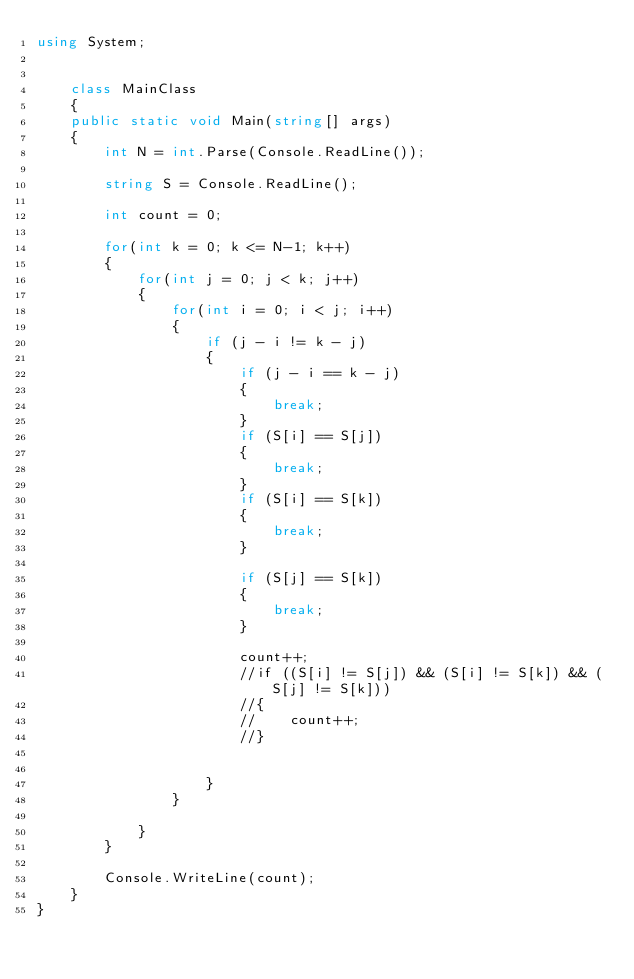Convert code to text. <code><loc_0><loc_0><loc_500><loc_500><_C#_>using System;


    class MainClass
    {
    public static void Main(string[] args)
    {
        int N = int.Parse(Console.ReadLine());

        string S = Console.ReadLine();

        int count = 0;

        for(int k = 0; k <= N-1; k++)
        {
            for(int j = 0; j < k; j++)
            {
                for(int i = 0; i < j; i++)
                {
                    if (j - i != k - j)
                    {
                        if (j - i == k - j)
                        {
                            break;
                        }
                        if (S[i] == S[j])
                        {
                            break;
                        }
                        if (S[i] == S[k])
                        {
                            break;
                        }

                        if (S[j] == S[k])
                        {
                            break;
                        }

                        count++;
                        //if ((S[i] != S[j]) && (S[i] != S[k]) && (S[j] != S[k]))
                        //{
                        //    count++;
                        //}


                    }
                }

            }
        }

        Console.WriteLine(count);
    }
}

</code> 